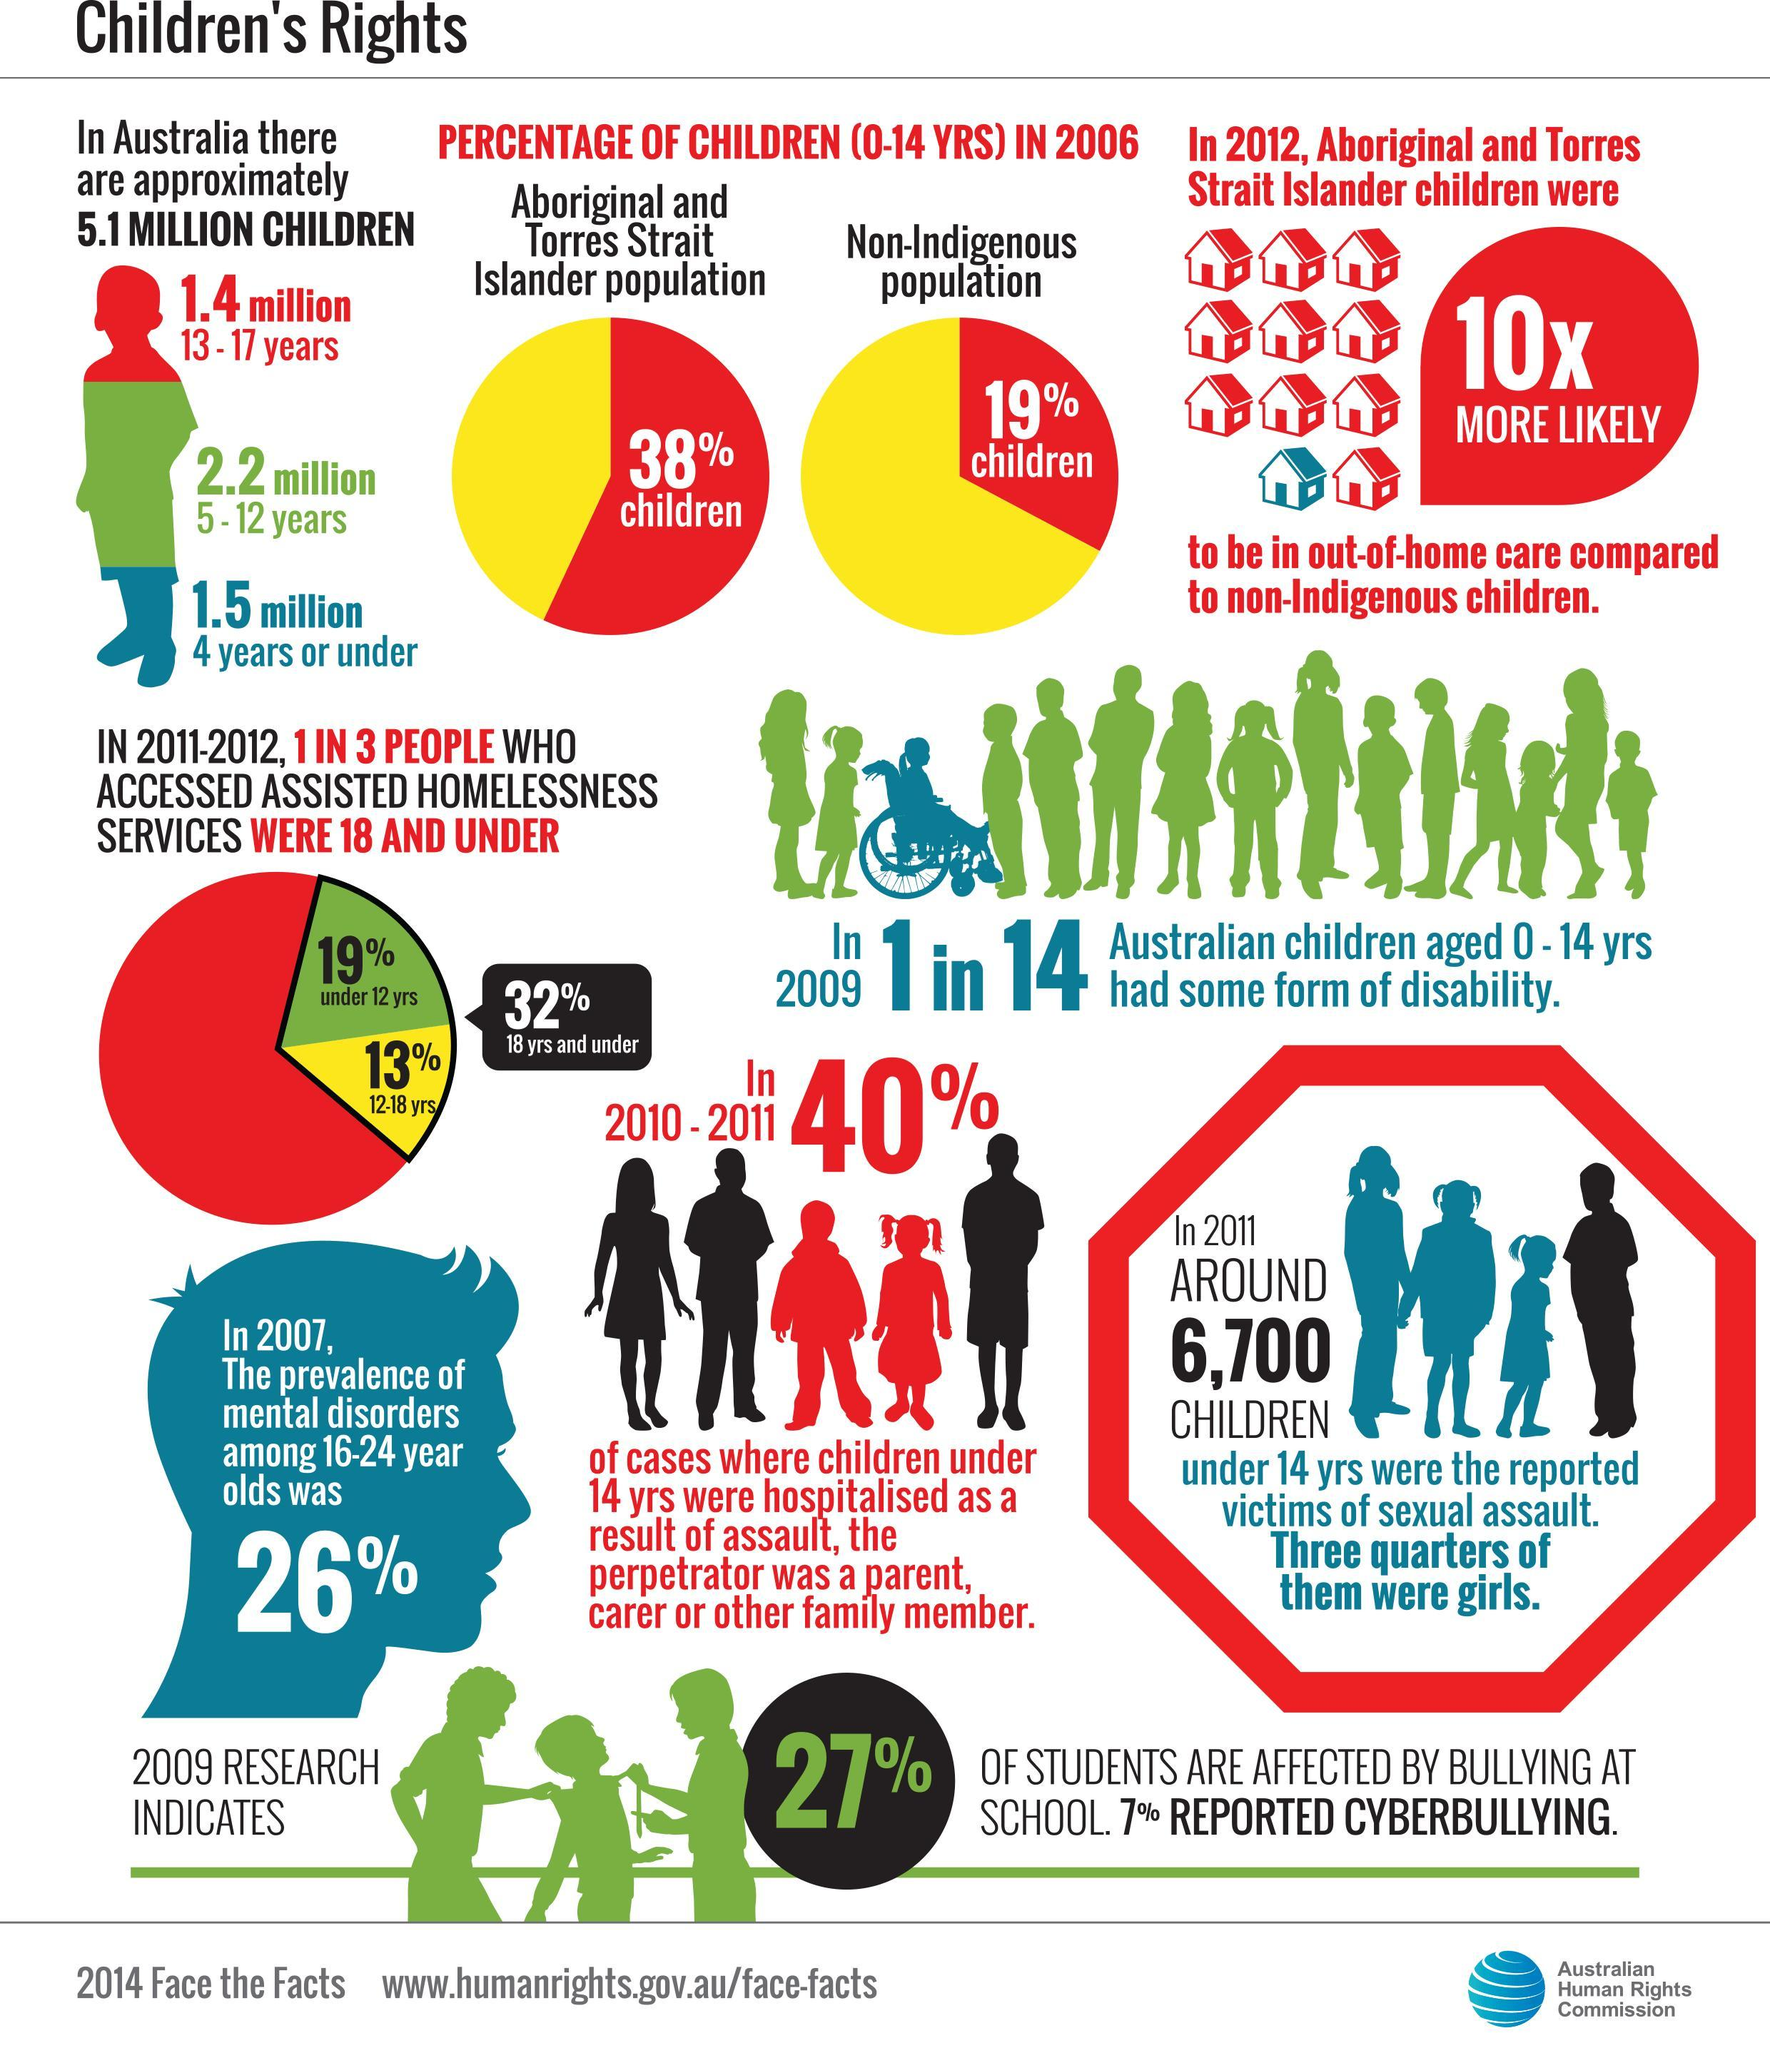What is the population of children in the age group of 4 years or under in Australia?
Answer the question with a short phrase. 1.5 million What is the percentage of Aboriginal & Torres Strait Islander children in the age group of 0-14 years in Australia in 2006? 38% What is the population of children in the age group of 5-12 years in Australia? 2.2 million What percentage of children in the age group of 12-18 years have accessed assisted homelessness services in Australia in 2011-12? 13% What percentage of children under 12 years have accessed assisted homelessness services in Australia in 2011-12? 19% What is the percentage of non-indigenous children in the age group of 0-14 years in Australia in 2006? 19% 